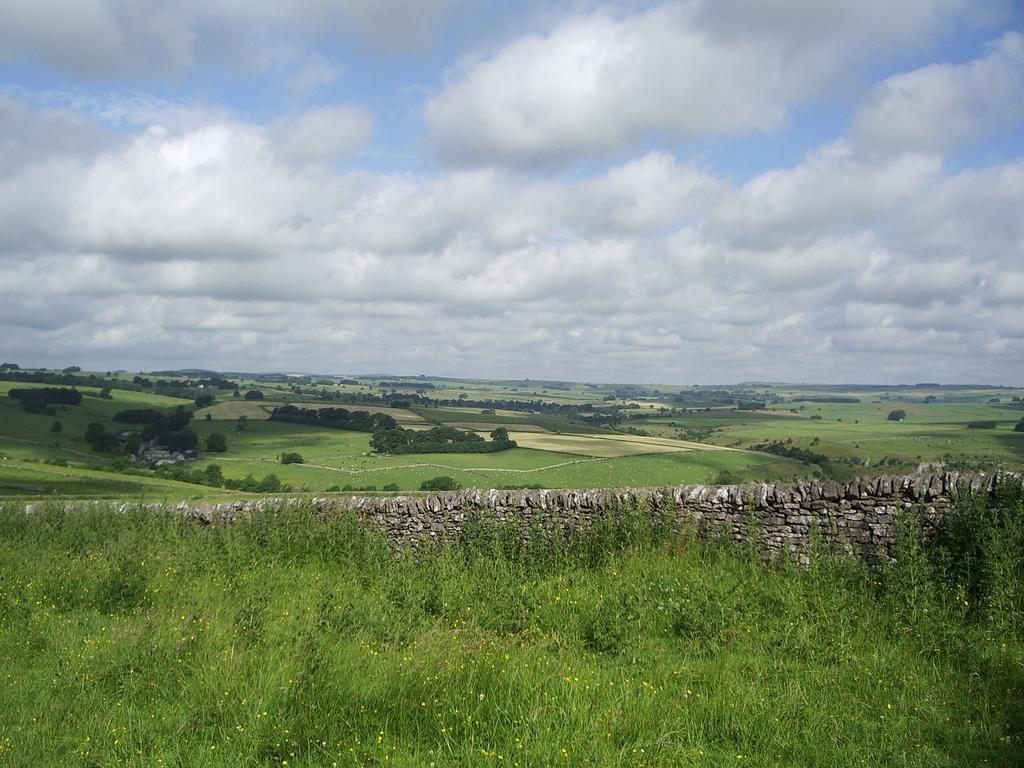How would you summarize this image in a sentence or two? This picture is clicked outside. In the foreground we can see the green grass, plants, rocks and some other objects. In the background we can see the sky which is full of clouds. 